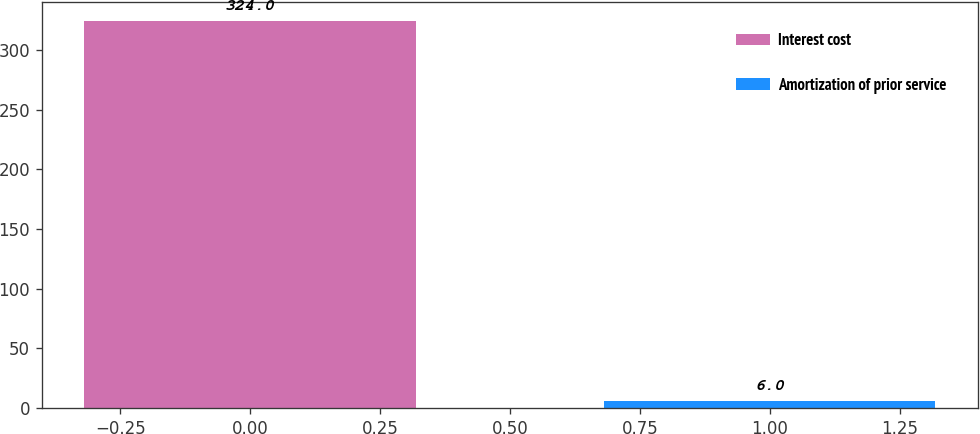<chart> <loc_0><loc_0><loc_500><loc_500><bar_chart><fcel>Interest cost<fcel>Amortization of prior service<nl><fcel>324<fcel>6<nl></chart> 